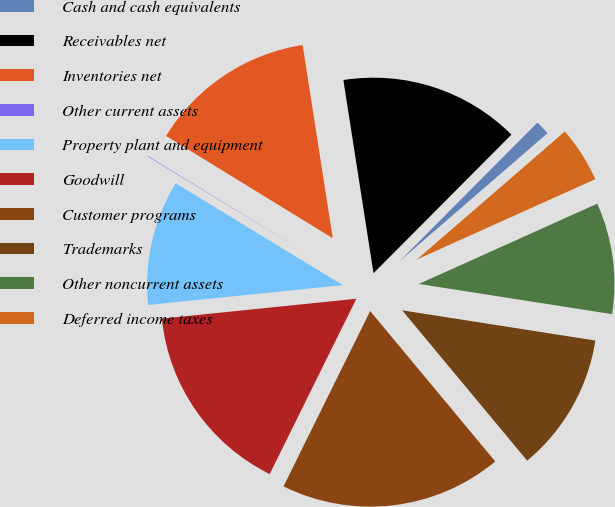Convert chart to OTSL. <chart><loc_0><loc_0><loc_500><loc_500><pie_chart><fcel>Cash and cash equivalents<fcel>Receivables net<fcel>Inventories net<fcel>Other current assets<fcel>Property plant and equipment<fcel>Goodwill<fcel>Customer programs<fcel>Trademarks<fcel>Other noncurrent assets<fcel>Deferred income taxes<nl><fcel>1.19%<fcel>14.92%<fcel>13.78%<fcel>0.04%<fcel>10.34%<fcel>16.07%<fcel>18.35%<fcel>11.49%<fcel>9.2%<fcel>4.62%<nl></chart> 